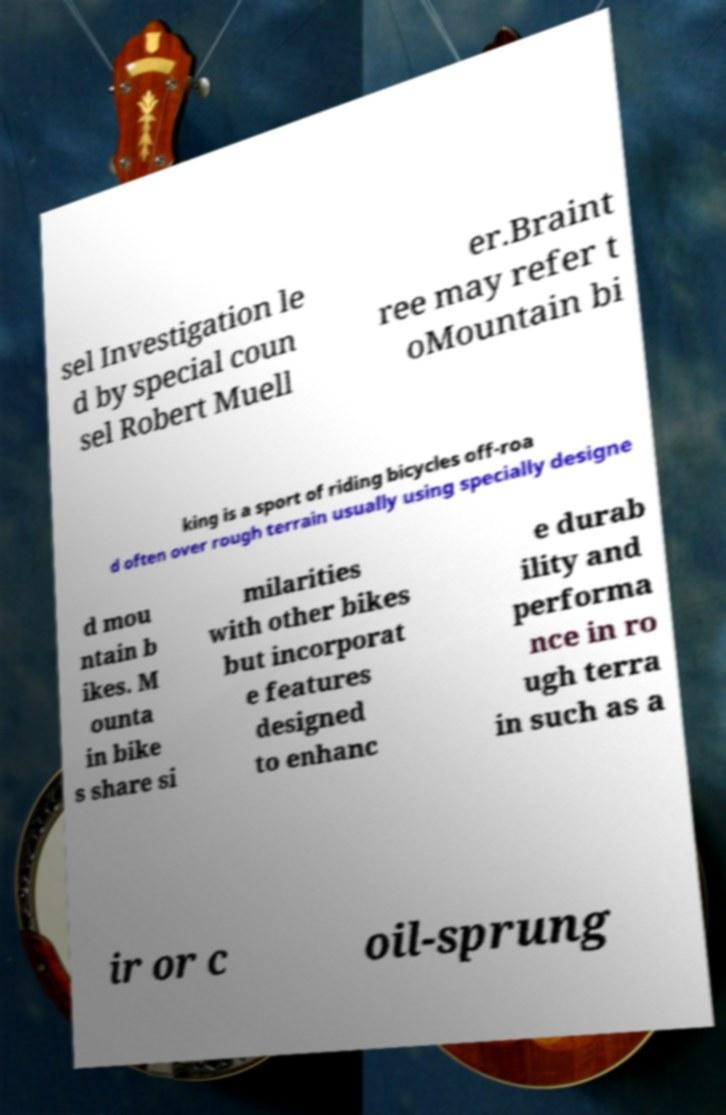I need the written content from this picture converted into text. Can you do that? sel Investigation le d by special coun sel Robert Muell er.Braint ree may refer t oMountain bi king is a sport of riding bicycles off-roa d often over rough terrain usually using specially designe d mou ntain b ikes. M ounta in bike s share si milarities with other bikes but incorporat e features designed to enhanc e durab ility and performa nce in ro ugh terra in such as a ir or c oil-sprung 